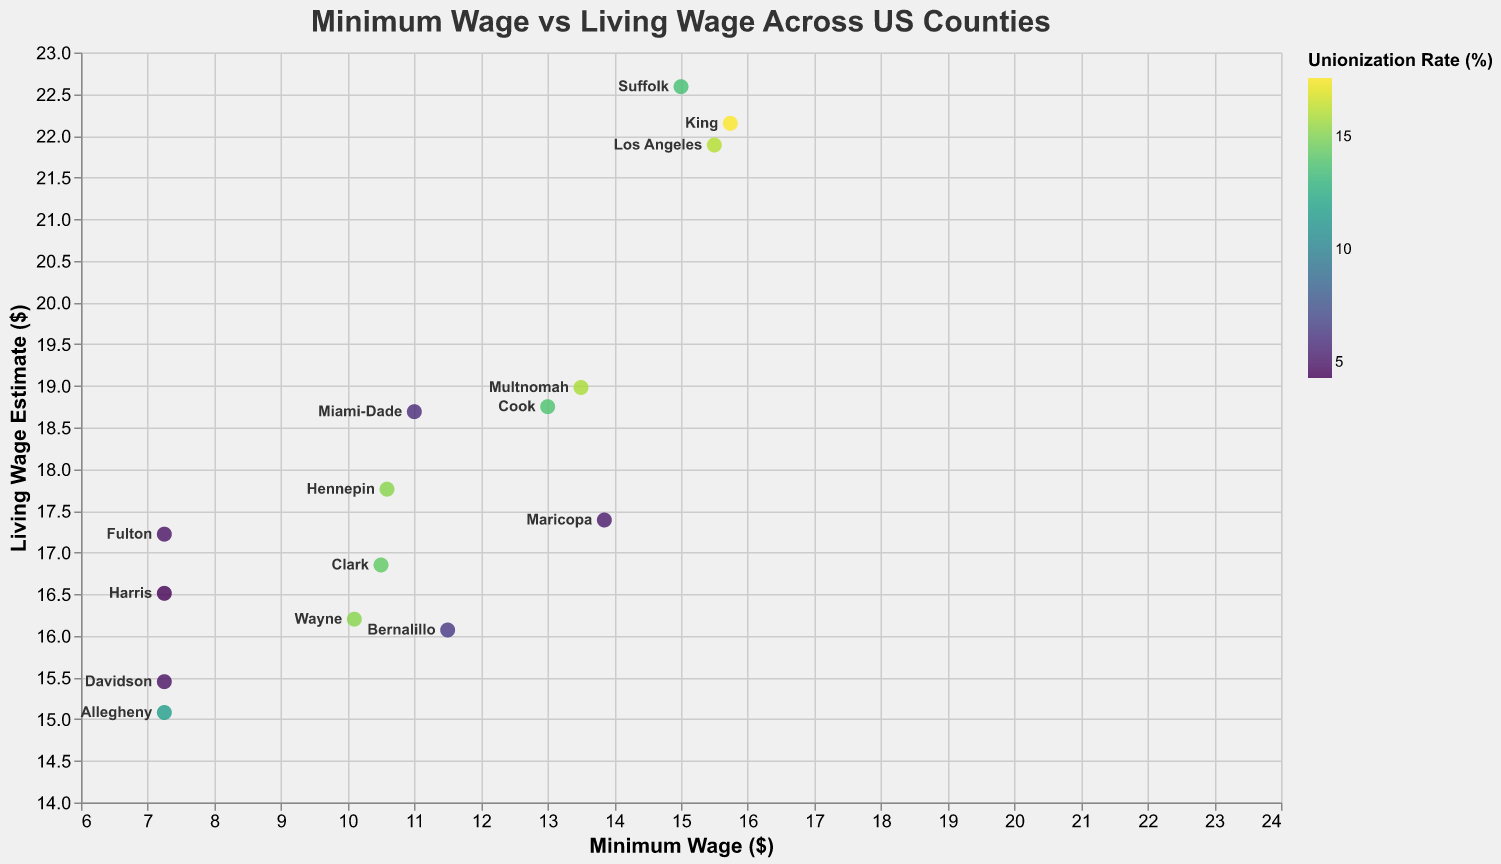How many counties have a minimum wage lower than $10.00? From the plot, review each data point and count those that have a minimum wage value below $10.00.
Answer: 5 Which county has the highest living wage estimate? Look at the 'Living Wage Estimate' axis, find the point that is at the maximum, and identify the corresponding county.
Answer: Suffolk What is the difference between the living wage estimates of Los Angeles and Harris counties? Find the 'Living Wage Estimate' values for Los Angeles and Harris counties, then calculate the difference: 21.89 - 16.51.
Answer: 5.38 Which county has the highest unionization rate? Look for the data point with the darkest shade of color on the plot, which represents the highest unionization rate.
Answer: King Is the minimum wage in Wayne county above or below the average minimum wage of all counties? Calculate the average minimum wage: (15.50 + 13.00 + 7.25 + 13.85 + 15.74 + 11.00 + 10.10 + 7.25 + 10.50 + 7.25 + 13.50 + 10.59 + 7.25 + 15.00 + 11.50) / 15 = 10.89; compare it with Wayne county's minimum wage of 10.10.
Answer: Below How does the unionization rate affect the gap between minimum and living wages? Compare the sizes of the gaps between minimum and living wages across counties with varying unionization rates. Counties with higher unionization rates tend to have smaller gaps.
Answer: Higher unionization rates tend to reduce the gap Which county has the smallest gap between minimum wage and living wage estimate? Calculate the gap for each county by subtracting the minimum wage from the living wage estimate and find the smallest value: Los Angeles (6.39), Cook (5.75), Harris (9.26), Maricopa (3.54), King (6.41), Miami-Dade (7.69), Wayne (6.10), Allegheny (7.83), Clark (6.35), Fulton (9.97), Multnomah (5.48), Hennepin (7.17), Davidson (8.20), Suffolk (7.59), Bernalillo (4.57).
Answer: Maricopa Is the minimum wage always lower than the living wage estimate in all counties? Observe the plot to ensure that each data point's minimum wage value is lower than its living wage estimate value.
Answer: Yes 